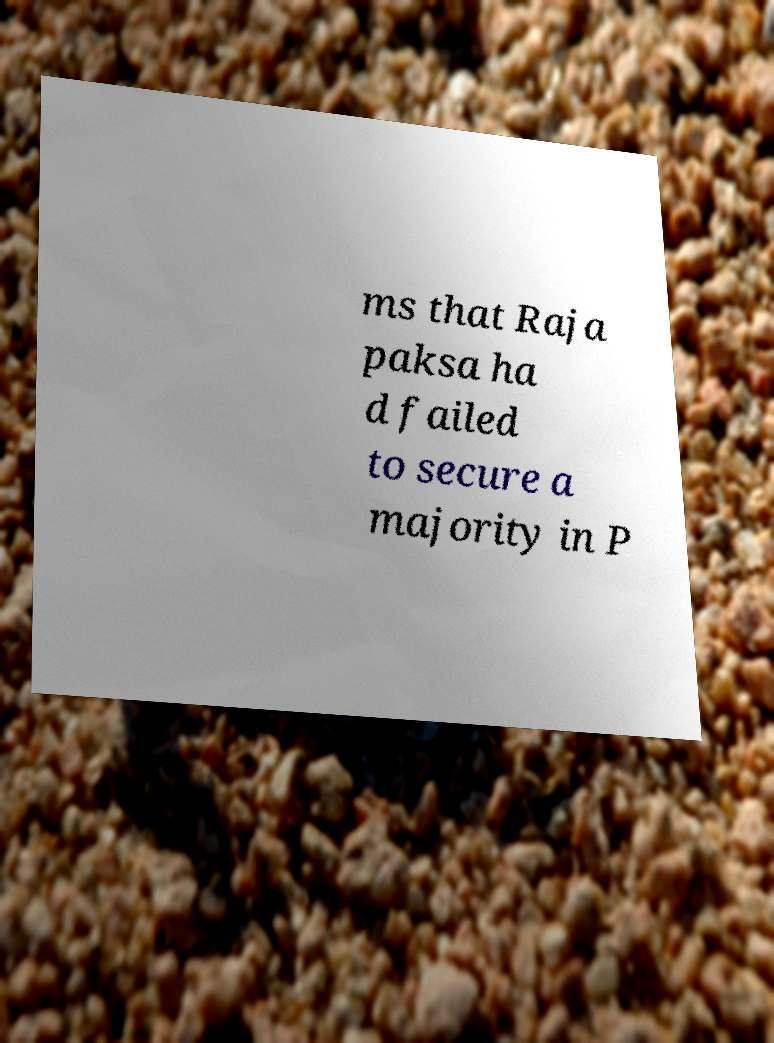I need the written content from this picture converted into text. Can you do that? ms that Raja paksa ha d failed to secure a majority in P 